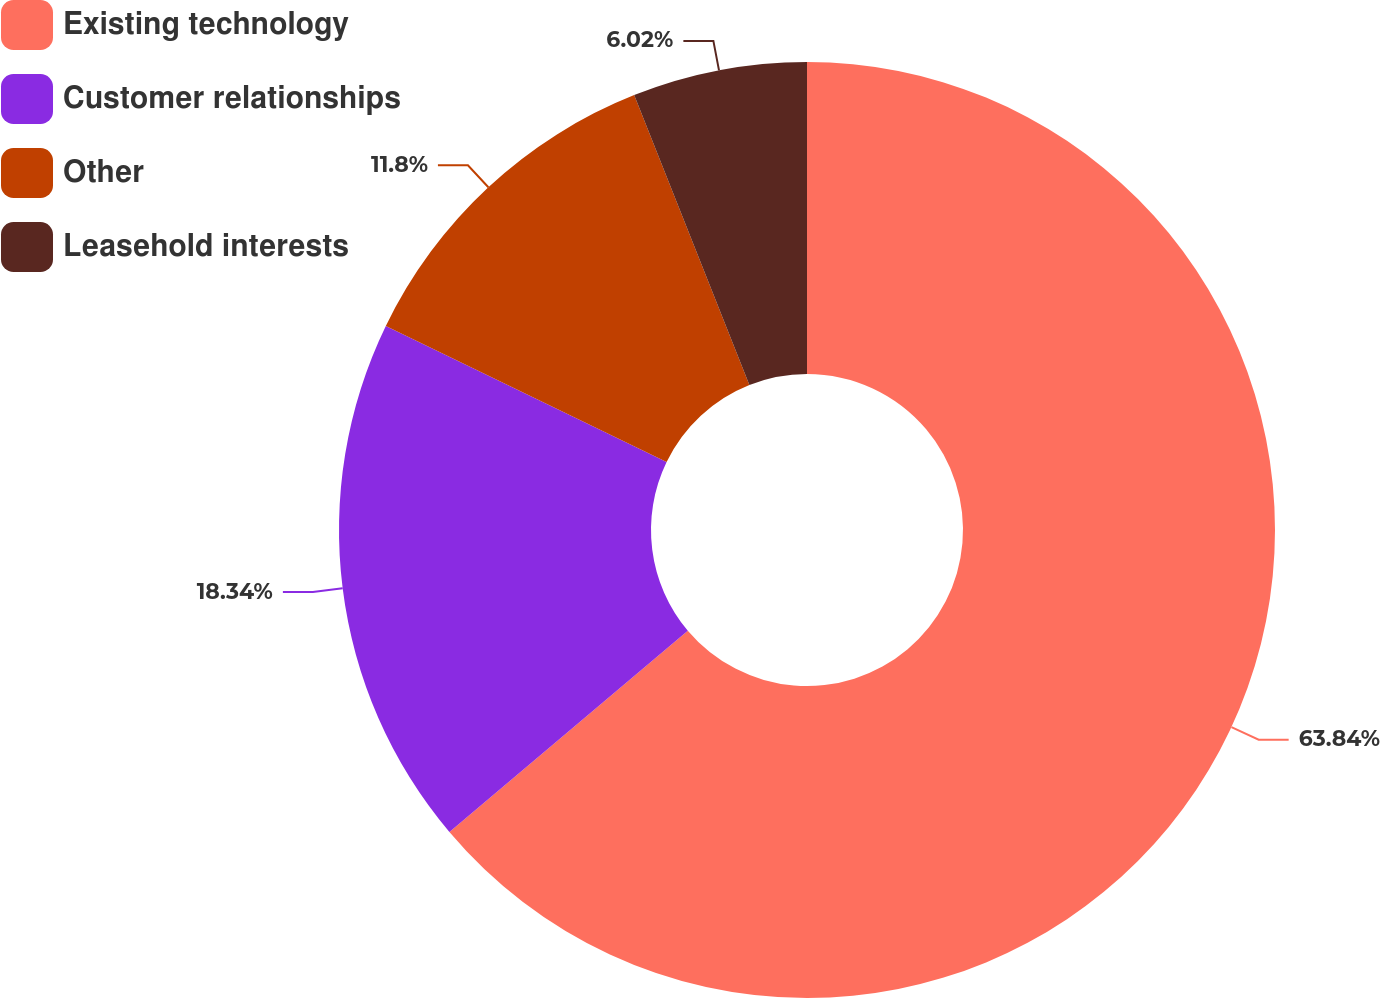Convert chart. <chart><loc_0><loc_0><loc_500><loc_500><pie_chart><fcel>Existing technology<fcel>Customer relationships<fcel>Other<fcel>Leasehold interests<nl><fcel>63.84%<fcel>18.34%<fcel>11.8%<fcel>6.02%<nl></chart> 